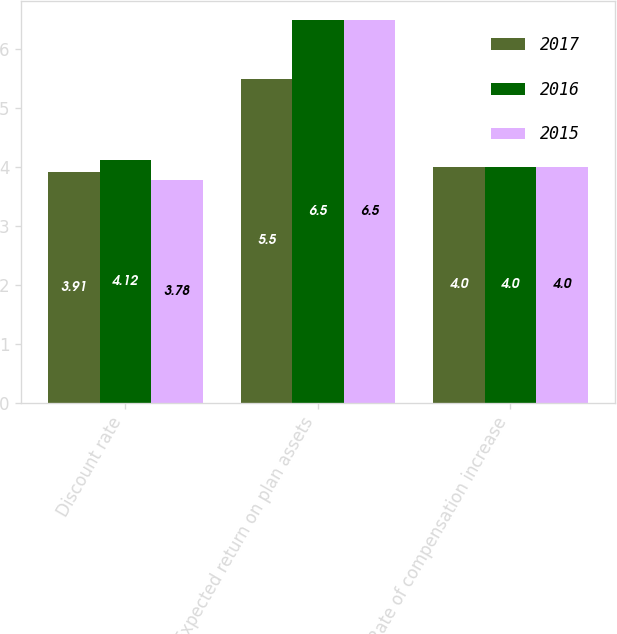<chart> <loc_0><loc_0><loc_500><loc_500><stacked_bar_chart><ecel><fcel>Discount rate<fcel>Expected return on plan assets<fcel>Rate of compensation increase<nl><fcel>2017<fcel>3.91<fcel>5.5<fcel>4<nl><fcel>2016<fcel>4.12<fcel>6.5<fcel>4<nl><fcel>2015<fcel>3.78<fcel>6.5<fcel>4<nl></chart> 